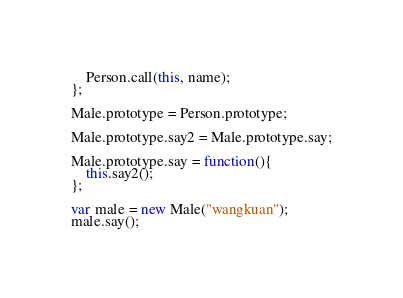Convert code to text. <code><loc_0><loc_0><loc_500><loc_500><_JavaScript_>	Person.call(this, name);
};

Male.prototype = Person.prototype;

Male.prototype.say2 = Male.prototype.say;

Male.prototype.say = function(){
	this.say2();
};

var male = new Male("wangkuan");
male.say();
</code> 